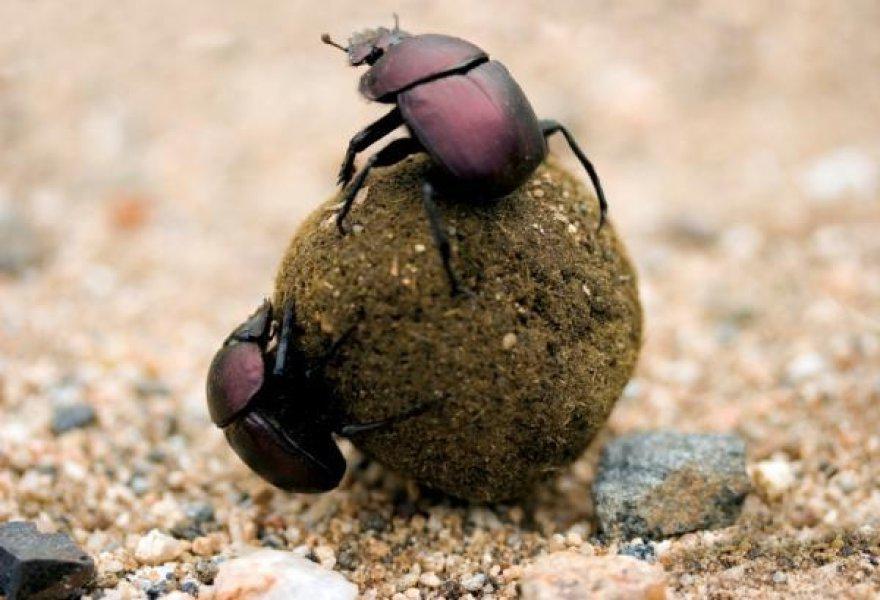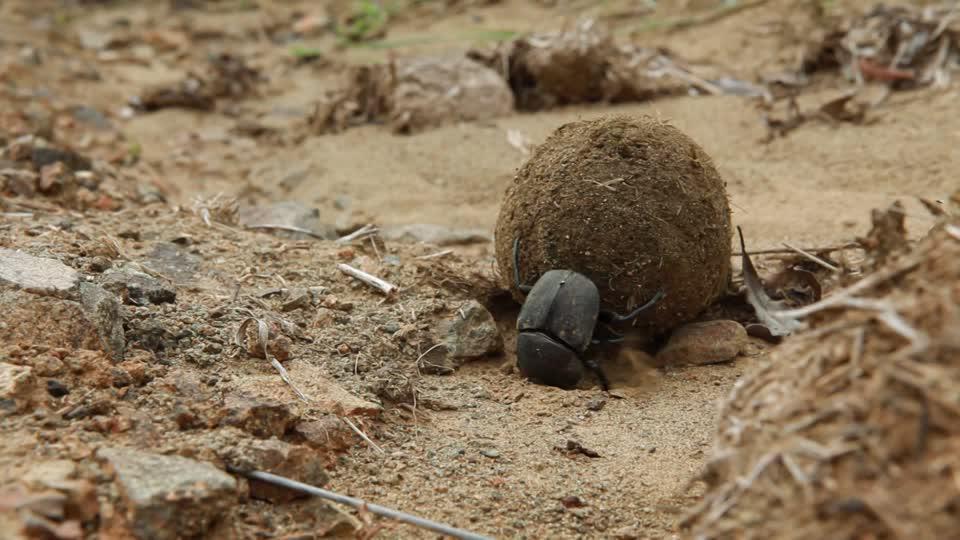The first image is the image on the left, the second image is the image on the right. Evaluate the accuracy of this statement regarding the images: "There are two beetles in one of the images.". Is it true? Answer yes or no. Yes. 